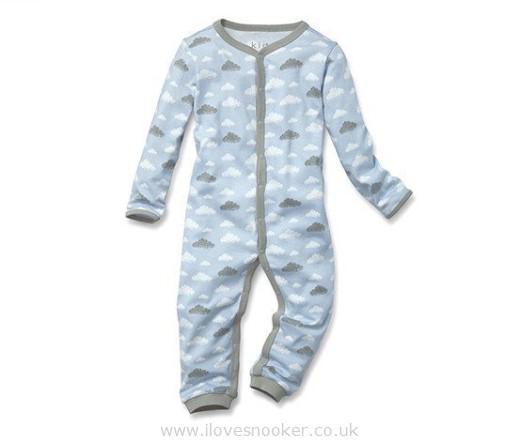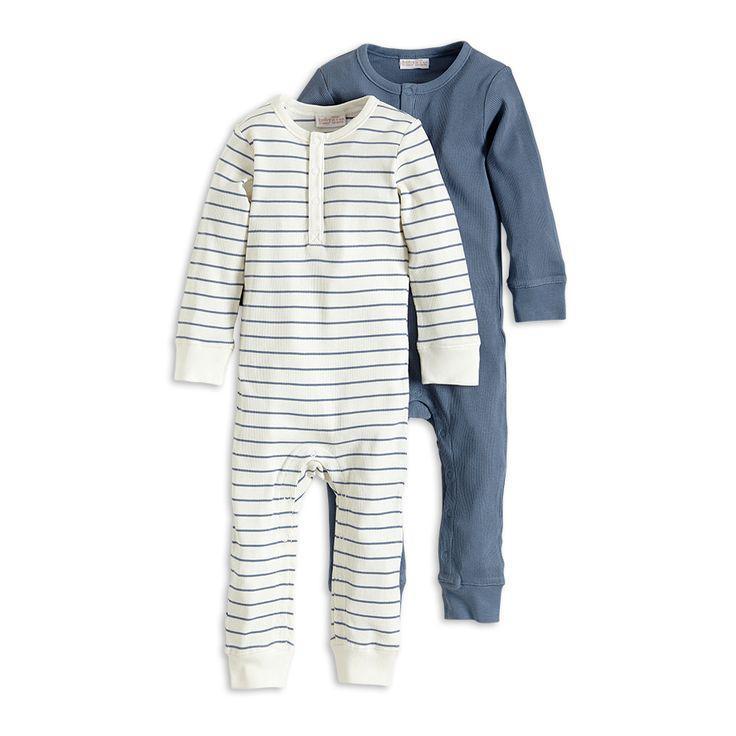The first image is the image on the left, the second image is the image on the right. Examine the images to the left and right. Is the description "One pair of men's blue pajamas with long sleeves is worn by a model, while a second pair is displayed on a hanger." accurate? Answer yes or no. No. The first image is the image on the left, the second image is the image on the right. Analyze the images presented: Is the assertion "An image shows two overlapping sleep outfits that are not worn by models or mannequins." valid? Answer yes or no. Yes. 